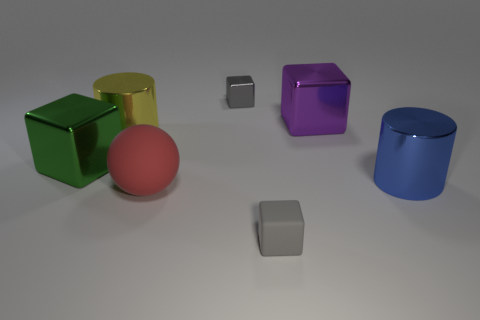How big is the metallic cylinder that is in front of the block on the left side of the red sphere?
Make the answer very short. Large. What is the color of the tiny rubber thing that is the same shape as the purple metal object?
Give a very brief answer. Gray. Do the rubber cube and the purple thing have the same size?
Keep it short and to the point. No. Are there the same number of big blue shiny things that are in front of the large blue thing and tiny yellow matte things?
Provide a succinct answer. Yes. There is a big metallic cylinder that is on the right side of the red matte object; are there any large metal cylinders that are in front of it?
Give a very brief answer. No. What size is the gray cube right of the tiny gray cube that is behind the tiny gray block in front of the large blue cylinder?
Offer a very short reply. Small. Are there the same number of big green spheres and red things?
Offer a very short reply. No. There is a large block behind the large cube that is left of the red rubber sphere; what is its material?
Your response must be concise. Metal. Are there any tiny things that have the same shape as the big blue object?
Offer a very short reply. No. What is the shape of the big yellow thing?
Your response must be concise. Cylinder. 